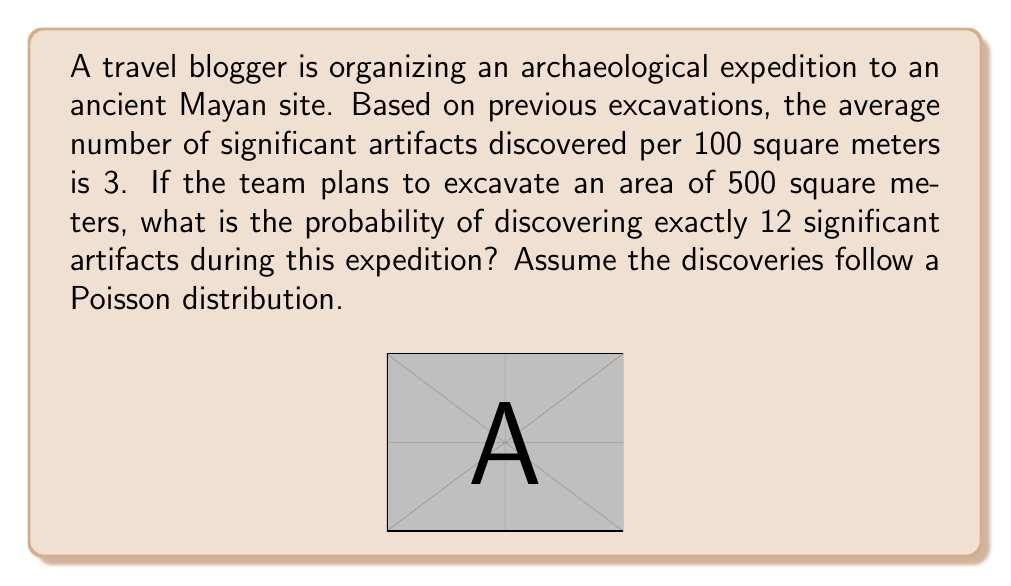What is the answer to this math problem? To solve this problem, we'll use the Poisson distribution formula:

$$P(X = k) = \frac{e^{-\lambda} \lambda^k}{k!}$$

Where:
- $\lambda$ is the average number of events in the given interval
- $k$ is the number of events we're calculating the probability for
- $e$ is Euler's number (approximately 2.71828)

Step 1: Calculate $\lambda$ for the given area
- Average artifacts per 100 sq m = 3
- Area to be excavated = 500 sq m
- $\lambda = 3 \times (500 / 100) = 15$

Step 2: Apply the Poisson distribution formula
- $k = 12$ (we want exactly 12 artifacts)
- $\lambda = 15$

$$P(X = 12) = \frac{e^{-15} 15^{12}}{12!}$$

Step 3: Calculate the result
- Use a calculator or computer to evaluate this expression
- $P(X = 12) \approx 0.0705$

Step 4: Convert to percentage
- $0.0705 \times 100\% = 7.05\%$

Therefore, the probability of discovering exactly 12 significant artifacts during this expedition is approximately 7.05%.
Answer: 7.05% 